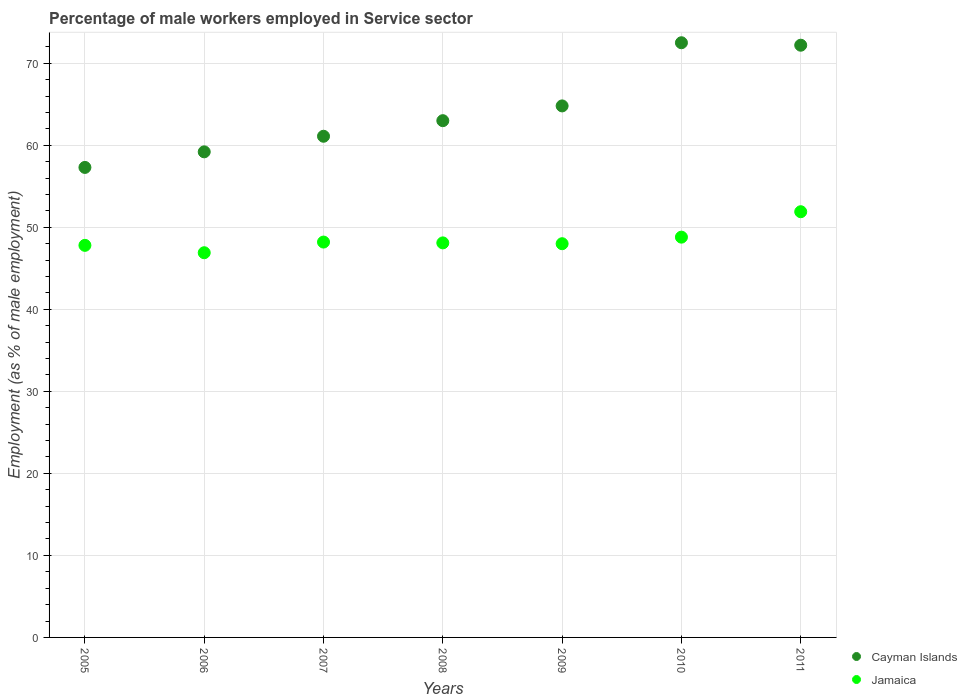How many different coloured dotlines are there?
Provide a succinct answer. 2. What is the percentage of male workers employed in Service sector in Jamaica in 2007?
Provide a succinct answer. 48.2. Across all years, what is the maximum percentage of male workers employed in Service sector in Jamaica?
Make the answer very short. 51.9. Across all years, what is the minimum percentage of male workers employed in Service sector in Cayman Islands?
Provide a succinct answer. 57.3. In which year was the percentage of male workers employed in Service sector in Jamaica maximum?
Your answer should be very brief. 2011. In which year was the percentage of male workers employed in Service sector in Jamaica minimum?
Offer a very short reply. 2006. What is the total percentage of male workers employed in Service sector in Jamaica in the graph?
Your answer should be very brief. 339.7. What is the difference between the percentage of male workers employed in Service sector in Cayman Islands in 2010 and that in 2011?
Give a very brief answer. 0.3. What is the difference between the percentage of male workers employed in Service sector in Cayman Islands in 2005 and the percentage of male workers employed in Service sector in Jamaica in 2007?
Your answer should be compact. 9.1. What is the average percentage of male workers employed in Service sector in Jamaica per year?
Ensure brevity in your answer.  48.53. What is the ratio of the percentage of male workers employed in Service sector in Cayman Islands in 2005 to that in 2011?
Your answer should be very brief. 0.79. What is the difference between the highest and the second highest percentage of male workers employed in Service sector in Jamaica?
Provide a short and direct response. 3.1. What is the difference between the highest and the lowest percentage of male workers employed in Service sector in Jamaica?
Make the answer very short. 5. In how many years, is the percentage of male workers employed in Service sector in Jamaica greater than the average percentage of male workers employed in Service sector in Jamaica taken over all years?
Ensure brevity in your answer.  2. Is the sum of the percentage of male workers employed in Service sector in Jamaica in 2007 and 2009 greater than the maximum percentage of male workers employed in Service sector in Cayman Islands across all years?
Your answer should be very brief. Yes. Is the percentage of male workers employed in Service sector in Cayman Islands strictly greater than the percentage of male workers employed in Service sector in Jamaica over the years?
Your answer should be very brief. Yes. Does the graph contain any zero values?
Give a very brief answer. No. Does the graph contain grids?
Your answer should be compact. Yes. What is the title of the graph?
Your answer should be compact. Percentage of male workers employed in Service sector. Does "Grenada" appear as one of the legend labels in the graph?
Offer a very short reply. No. What is the label or title of the X-axis?
Give a very brief answer. Years. What is the label or title of the Y-axis?
Your answer should be compact. Employment (as % of male employment). What is the Employment (as % of male employment) of Cayman Islands in 2005?
Offer a terse response. 57.3. What is the Employment (as % of male employment) of Jamaica in 2005?
Make the answer very short. 47.8. What is the Employment (as % of male employment) in Cayman Islands in 2006?
Your response must be concise. 59.2. What is the Employment (as % of male employment) in Jamaica in 2006?
Ensure brevity in your answer.  46.9. What is the Employment (as % of male employment) of Cayman Islands in 2007?
Keep it short and to the point. 61.1. What is the Employment (as % of male employment) of Jamaica in 2007?
Your answer should be very brief. 48.2. What is the Employment (as % of male employment) in Cayman Islands in 2008?
Provide a succinct answer. 63. What is the Employment (as % of male employment) of Jamaica in 2008?
Make the answer very short. 48.1. What is the Employment (as % of male employment) in Cayman Islands in 2009?
Offer a terse response. 64.8. What is the Employment (as % of male employment) of Jamaica in 2009?
Offer a very short reply. 48. What is the Employment (as % of male employment) in Cayman Islands in 2010?
Give a very brief answer. 72.5. What is the Employment (as % of male employment) of Jamaica in 2010?
Your answer should be very brief. 48.8. What is the Employment (as % of male employment) in Cayman Islands in 2011?
Give a very brief answer. 72.2. What is the Employment (as % of male employment) of Jamaica in 2011?
Ensure brevity in your answer.  51.9. Across all years, what is the maximum Employment (as % of male employment) in Cayman Islands?
Give a very brief answer. 72.5. Across all years, what is the maximum Employment (as % of male employment) of Jamaica?
Your response must be concise. 51.9. Across all years, what is the minimum Employment (as % of male employment) of Cayman Islands?
Give a very brief answer. 57.3. Across all years, what is the minimum Employment (as % of male employment) of Jamaica?
Offer a terse response. 46.9. What is the total Employment (as % of male employment) in Cayman Islands in the graph?
Keep it short and to the point. 450.1. What is the total Employment (as % of male employment) of Jamaica in the graph?
Make the answer very short. 339.7. What is the difference between the Employment (as % of male employment) in Cayman Islands in 2005 and that in 2006?
Provide a succinct answer. -1.9. What is the difference between the Employment (as % of male employment) of Jamaica in 2005 and that in 2007?
Ensure brevity in your answer.  -0.4. What is the difference between the Employment (as % of male employment) in Cayman Islands in 2005 and that in 2008?
Offer a terse response. -5.7. What is the difference between the Employment (as % of male employment) in Jamaica in 2005 and that in 2008?
Your answer should be compact. -0.3. What is the difference between the Employment (as % of male employment) of Cayman Islands in 2005 and that in 2009?
Provide a short and direct response. -7.5. What is the difference between the Employment (as % of male employment) in Cayman Islands in 2005 and that in 2010?
Your response must be concise. -15.2. What is the difference between the Employment (as % of male employment) of Cayman Islands in 2005 and that in 2011?
Ensure brevity in your answer.  -14.9. What is the difference between the Employment (as % of male employment) in Jamaica in 2005 and that in 2011?
Your response must be concise. -4.1. What is the difference between the Employment (as % of male employment) in Cayman Islands in 2006 and that in 2007?
Your answer should be compact. -1.9. What is the difference between the Employment (as % of male employment) of Jamaica in 2006 and that in 2008?
Keep it short and to the point. -1.2. What is the difference between the Employment (as % of male employment) in Jamaica in 2006 and that in 2009?
Provide a short and direct response. -1.1. What is the difference between the Employment (as % of male employment) in Cayman Islands in 2006 and that in 2011?
Make the answer very short. -13. What is the difference between the Employment (as % of male employment) in Cayman Islands in 2007 and that in 2008?
Provide a short and direct response. -1.9. What is the difference between the Employment (as % of male employment) of Jamaica in 2007 and that in 2008?
Provide a succinct answer. 0.1. What is the difference between the Employment (as % of male employment) of Jamaica in 2007 and that in 2009?
Offer a terse response. 0.2. What is the difference between the Employment (as % of male employment) of Cayman Islands in 2007 and that in 2011?
Provide a short and direct response. -11.1. What is the difference between the Employment (as % of male employment) in Jamaica in 2008 and that in 2009?
Ensure brevity in your answer.  0.1. What is the difference between the Employment (as % of male employment) in Cayman Islands in 2008 and that in 2011?
Make the answer very short. -9.2. What is the difference between the Employment (as % of male employment) of Jamaica in 2008 and that in 2011?
Provide a succinct answer. -3.8. What is the difference between the Employment (as % of male employment) of Cayman Islands in 2009 and that in 2011?
Your answer should be very brief. -7.4. What is the difference between the Employment (as % of male employment) of Cayman Islands in 2010 and that in 2011?
Your response must be concise. 0.3. What is the difference between the Employment (as % of male employment) in Jamaica in 2010 and that in 2011?
Keep it short and to the point. -3.1. What is the difference between the Employment (as % of male employment) of Cayman Islands in 2006 and the Employment (as % of male employment) of Jamaica in 2007?
Provide a succinct answer. 11. What is the difference between the Employment (as % of male employment) in Cayman Islands in 2006 and the Employment (as % of male employment) in Jamaica in 2010?
Your response must be concise. 10.4. What is the difference between the Employment (as % of male employment) of Cayman Islands in 2006 and the Employment (as % of male employment) of Jamaica in 2011?
Give a very brief answer. 7.3. What is the difference between the Employment (as % of male employment) in Cayman Islands in 2007 and the Employment (as % of male employment) in Jamaica in 2008?
Your answer should be very brief. 13. What is the difference between the Employment (as % of male employment) of Cayman Islands in 2007 and the Employment (as % of male employment) of Jamaica in 2011?
Offer a terse response. 9.2. What is the difference between the Employment (as % of male employment) in Cayman Islands in 2008 and the Employment (as % of male employment) in Jamaica in 2010?
Provide a succinct answer. 14.2. What is the difference between the Employment (as % of male employment) of Cayman Islands in 2009 and the Employment (as % of male employment) of Jamaica in 2010?
Your response must be concise. 16. What is the difference between the Employment (as % of male employment) in Cayman Islands in 2010 and the Employment (as % of male employment) in Jamaica in 2011?
Your answer should be very brief. 20.6. What is the average Employment (as % of male employment) of Cayman Islands per year?
Provide a short and direct response. 64.3. What is the average Employment (as % of male employment) of Jamaica per year?
Offer a terse response. 48.53. In the year 2005, what is the difference between the Employment (as % of male employment) in Cayman Islands and Employment (as % of male employment) in Jamaica?
Keep it short and to the point. 9.5. In the year 2006, what is the difference between the Employment (as % of male employment) in Cayman Islands and Employment (as % of male employment) in Jamaica?
Offer a very short reply. 12.3. In the year 2008, what is the difference between the Employment (as % of male employment) of Cayman Islands and Employment (as % of male employment) of Jamaica?
Keep it short and to the point. 14.9. In the year 2009, what is the difference between the Employment (as % of male employment) of Cayman Islands and Employment (as % of male employment) of Jamaica?
Provide a short and direct response. 16.8. In the year 2010, what is the difference between the Employment (as % of male employment) of Cayman Islands and Employment (as % of male employment) of Jamaica?
Make the answer very short. 23.7. In the year 2011, what is the difference between the Employment (as % of male employment) of Cayman Islands and Employment (as % of male employment) of Jamaica?
Your answer should be compact. 20.3. What is the ratio of the Employment (as % of male employment) of Cayman Islands in 2005 to that in 2006?
Provide a short and direct response. 0.97. What is the ratio of the Employment (as % of male employment) of Jamaica in 2005 to that in 2006?
Provide a succinct answer. 1.02. What is the ratio of the Employment (as % of male employment) in Cayman Islands in 2005 to that in 2007?
Ensure brevity in your answer.  0.94. What is the ratio of the Employment (as % of male employment) in Cayman Islands in 2005 to that in 2008?
Give a very brief answer. 0.91. What is the ratio of the Employment (as % of male employment) in Jamaica in 2005 to that in 2008?
Keep it short and to the point. 0.99. What is the ratio of the Employment (as % of male employment) in Cayman Islands in 2005 to that in 2009?
Your answer should be compact. 0.88. What is the ratio of the Employment (as % of male employment) in Jamaica in 2005 to that in 2009?
Provide a short and direct response. 1. What is the ratio of the Employment (as % of male employment) of Cayman Islands in 2005 to that in 2010?
Your answer should be very brief. 0.79. What is the ratio of the Employment (as % of male employment) of Jamaica in 2005 to that in 2010?
Give a very brief answer. 0.98. What is the ratio of the Employment (as % of male employment) in Cayman Islands in 2005 to that in 2011?
Your response must be concise. 0.79. What is the ratio of the Employment (as % of male employment) of Jamaica in 2005 to that in 2011?
Ensure brevity in your answer.  0.92. What is the ratio of the Employment (as % of male employment) of Cayman Islands in 2006 to that in 2007?
Keep it short and to the point. 0.97. What is the ratio of the Employment (as % of male employment) of Jamaica in 2006 to that in 2007?
Ensure brevity in your answer.  0.97. What is the ratio of the Employment (as % of male employment) of Cayman Islands in 2006 to that in 2008?
Provide a succinct answer. 0.94. What is the ratio of the Employment (as % of male employment) in Jamaica in 2006 to that in 2008?
Offer a very short reply. 0.98. What is the ratio of the Employment (as % of male employment) of Cayman Islands in 2006 to that in 2009?
Ensure brevity in your answer.  0.91. What is the ratio of the Employment (as % of male employment) of Jamaica in 2006 to that in 2009?
Your answer should be compact. 0.98. What is the ratio of the Employment (as % of male employment) in Cayman Islands in 2006 to that in 2010?
Make the answer very short. 0.82. What is the ratio of the Employment (as % of male employment) of Jamaica in 2006 to that in 2010?
Ensure brevity in your answer.  0.96. What is the ratio of the Employment (as % of male employment) in Cayman Islands in 2006 to that in 2011?
Make the answer very short. 0.82. What is the ratio of the Employment (as % of male employment) of Jamaica in 2006 to that in 2011?
Keep it short and to the point. 0.9. What is the ratio of the Employment (as % of male employment) of Cayman Islands in 2007 to that in 2008?
Provide a succinct answer. 0.97. What is the ratio of the Employment (as % of male employment) of Cayman Islands in 2007 to that in 2009?
Offer a terse response. 0.94. What is the ratio of the Employment (as % of male employment) of Cayman Islands in 2007 to that in 2010?
Offer a very short reply. 0.84. What is the ratio of the Employment (as % of male employment) of Cayman Islands in 2007 to that in 2011?
Your response must be concise. 0.85. What is the ratio of the Employment (as % of male employment) in Jamaica in 2007 to that in 2011?
Offer a terse response. 0.93. What is the ratio of the Employment (as % of male employment) in Cayman Islands in 2008 to that in 2009?
Provide a succinct answer. 0.97. What is the ratio of the Employment (as % of male employment) in Jamaica in 2008 to that in 2009?
Keep it short and to the point. 1. What is the ratio of the Employment (as % of male employment) in Cayman Islands in 2008 to that in 2010?
Offer a terse response. 0.87. What is the ratio of the Employment (as % of male employment) in Jamaica in 2008 to that in 2010?
Your response must be concise. 0.99. What is the ratio of the Employment (as % of male employment) of Cayman Islands in 2008 to that in 2011?
Ensure brevity in your answer.  0.87. What is the ratio of the Employment (as % of male employment) in Jamaica in 2008 to that in 2011?
Your answer should be very brief. 0.93. What is the ratio of the Employment (as % of male employment) in Cayman Islands in 2009 to that in 2010?
Keep it short and to the point. 0.89. What is the ratio of the Employment (as % of male employment) in Jamaica in 2009 to that in 2010?
Offer a very short reply. 0.98. What is the ratio of the Employment (as % of male employment) of Cayman Islands in 2009 to that in 2011?
Your answer should be compact. 0.9. What is the ratio of the Employment (as % of male employment) in Jamaica in 2009 to that in 2011?
Give a very brief answer. 0.92. What is the ratio of the Employment (as % of male employment) of Cayman Islands in 2010 to that in 2011?
Give a very brief answer. 1. What is the ratio of the Employment (as % of male employment) of Jamaica in 2010 to that in 2011?
Make the answer very short. 0.94. What is the difference between the highest and the second highest Employment (as % of male employment) in Jamaica?
Ensure brevity in your answer.  3.1. What is the difference between the highest and the lowest Employment (as % of male employment) in Cayman Islands?
Offer a terse response. 15.2. 